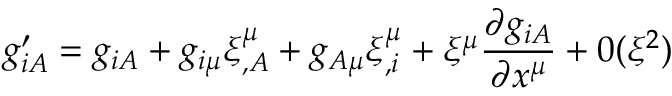Convert formula to latex. <formula><loc_0><loc_0><loc_500><loc_500>g _ { i A } ^ { \prime } = g _ { i A } + g _ { i \mu } \xi _ { , A } ^ { \mu } + g _ { A \mu } \xi _ { , i } ^ { \mu } + \xi ^ { \mu } \frac { \partial g _ { i A } } { \partial x ^ { \mu } } + 0 ( \xi ^ { 2 } )</formula> 